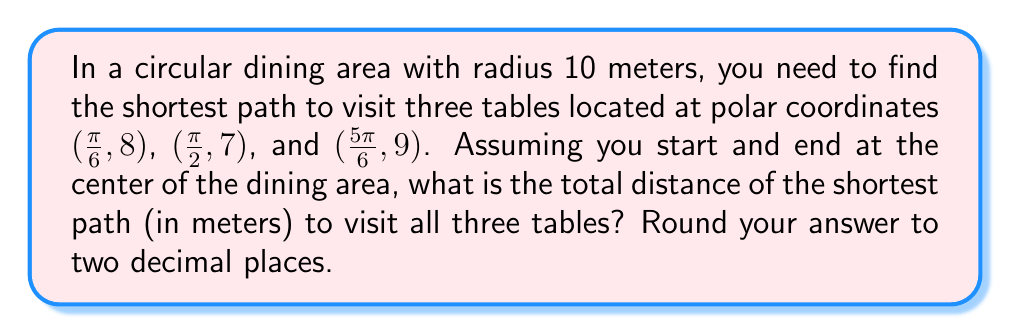Could you help me with this problem? To solve this problem, we'll follow these steps:

1) First, let's visualize the problem using Asymptote:

[asy]
import geometry;

size(200);
pair O=(0,0);
draw(circle(O,10));
pair A = 8*dir(30);
pair B = 7*dir(90);
pair C = 9*dir(150);
dot("O",O,S);
dot("A",A,NE);
dot("B",B,N);
dot("C",C,NW);
draw(O--A--B--C--O,red);
[/asy]

2) The shortest path will be: Center (O) → Table A → Table B → Table C → Center (O)

3) We need to calculate the distances:
   a) O to A: $\sqrt{8^2} = 8$ m
   b) A to B: We can use the law of cosines:
      $$d_{AB} = \sqrt{8^2 + 7^2 - 2(8)(7)\cos(\frac{\pi}{3})}$$
   c) B to C: Again, using the law of cosines:
      $$d_{BC} = \sqrt{7^2 + 9^2 - 2(7)(9)\cos(\frac{\pi}{3})}$$
   d) C to O: $\sqrt{9^2} = 9$ m

4) Let's calculate the distances:
   a) O to A: 8 m
   b) A to B: $\sqrt{64 + 49 - 112(\frac{1}{2})} = \sqrt{57} = 7.55$ m
   c) B to C: $\sqrt{49 + 81 - 126(\frac{1}{2})} = \sqrt{67} = 8.19$ m
   d) C to O: 9 m

5) The total distance is the sum of these distances:
   $8 + 7.55 + 8.19 + 9 = 32.74$ m
Answer: $32.74$ meters 